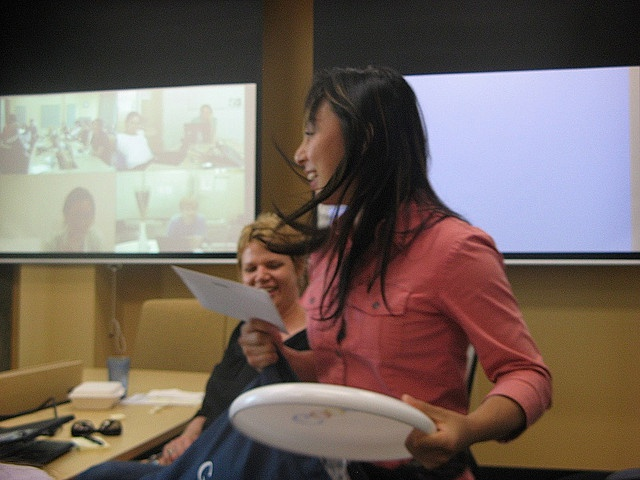Describe the objects in this image and their specific colors. I can see people in black, maroon, and brown tones, tv in black, beige, lightgray, and darkgray tones, tv in black, lavender, and darkgray tones, frisbee in black, gray, and darkgray tones, and people in black, brown, and maroon tones in this image. 